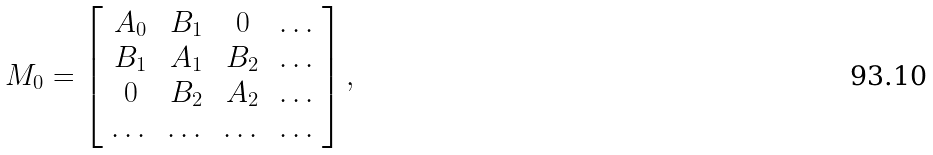<formula> <loc_0><loc_0><loc_500><loc_500>M _ { 0 } = \left [ \begin{array} { c c c c } A _ { 0 } & B _ { 1 } & 0 & \dots \\ B _ { 1 } & A _ { 1 } & B _ { 2 } & \dots \\ 0 & B _ { 2 } & A _ { 2 } & \dots \\ \dots & \dots & \dots & \dots \end{array} \right ] ,</formula> 